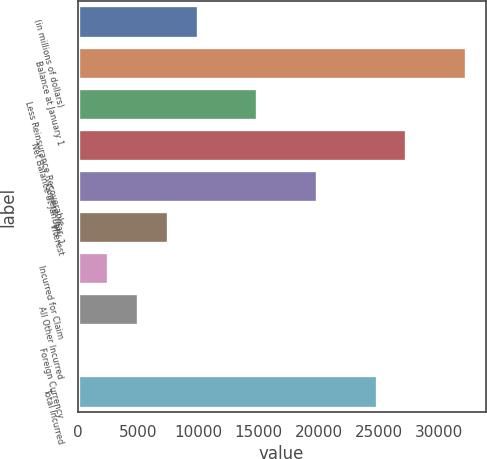Convert chart to OTSL. <chart><loc_0><loc_0><loc_500><loc_500><bar_chart><fcel>(in millions of dollars)<fcel>Balance at January 1<fcel>Less Reinsurance Recoverable<fcel>Net Balance at January 1<fcel>Current Year<fcel>Interest<fcel>Incurred for Claim<fcel>All Other Incurred<fcel>Foreign Currency<fcel>Total Incurred<nl><fcel>9936.22<fcel>32216.9<fcel>14887.5<fcel>27265.6<fcel>19838.7<fcel>7460.59<fcel>2509.33<fcel>4984.96<fcel>33.7<fcel>24790<nl></chart> 